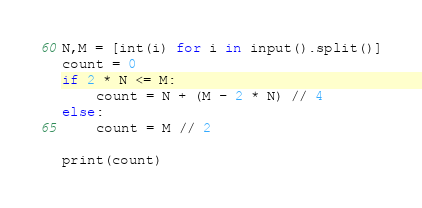<code> <loc_0><loc_0><loc_500><loc_500><_Python_>N,M = [int(i) for i in input().split()]
count = 0
if 2 * N <= M:
    count = N + (M - 2 * N) // 4
else:
    count = M // 2

print(count)
</code> 